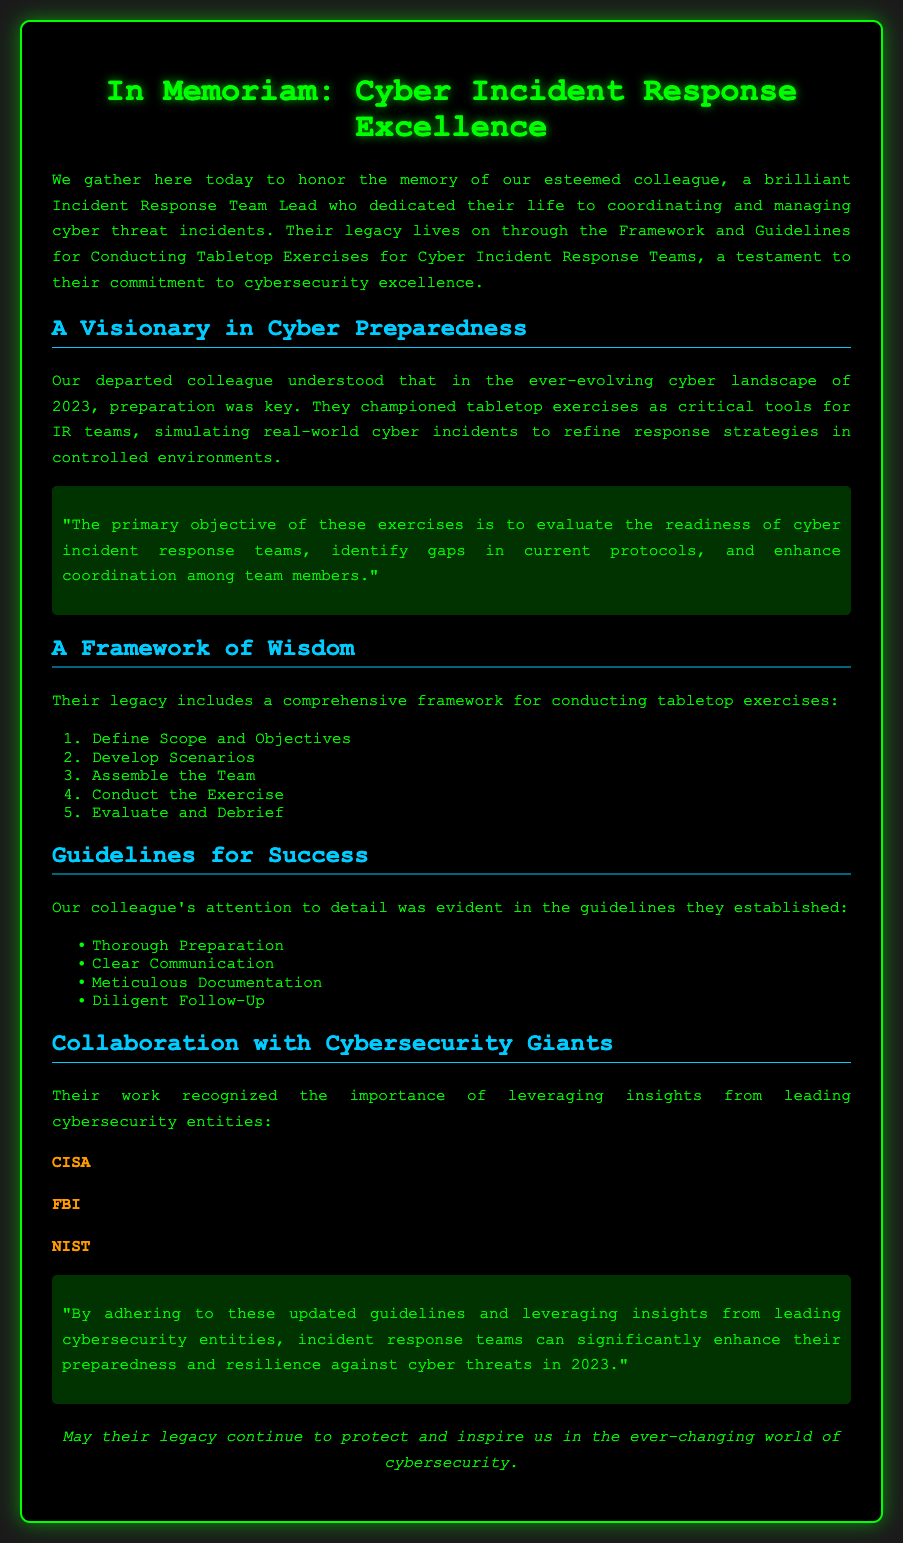What is the title of the document? The title is prominently displayed at the top of the document, indicating the theme and focus.
Answer: In Memoriam: Cyber Incident Response Excellence What are the primary objectives of tabletop exercises? The document states the primary objective clearly, emphasizing evaluation and improvement aspects in the context of cyber readiness.
Answer: Evaluate the readiness of cyber incident response teams What year is highlighted in the document? The document emphasizes the importance of preparedness in a specific contemporary context, which is mentioned explicitly in the introduction.
Answer: 2023 What is the first step in the comprehensive framework for conducting tabletop exercises? The order of steps is listed in the document, starting with a clear and defined initial action.
Answer: Define Scope and Objectives Which cybersecurity entities are mentioned for collaboration? The document acknowledges key organizations that are influential in the cybersecurity field by name.
Answer: CISA, FBI, NIST What aspect of preparation is highlighted in the guidelines? The guidelines section of the document lists important elements related to preparation, indicating a structured approach.
Answer: Thorough Preparation What does the document suggest is essential for effective communication during exercises? The guidelines highlight the necessary elements for facilitating effective interactions among team members during the exercises.
Answer: Clear Communication How is the reflection on the colleague characterized in the document? The opening part of the document sets a tone of reflection and respect for the contributions made by the colleague posthumously.
Answer: Honor the memory of our esteemed colleague What follows the evaluation phase in the comprehensive framework? The sequential nature of actions is clearly laid out in the framework, indicating what should come after evaluation.
Answer: Debrief 